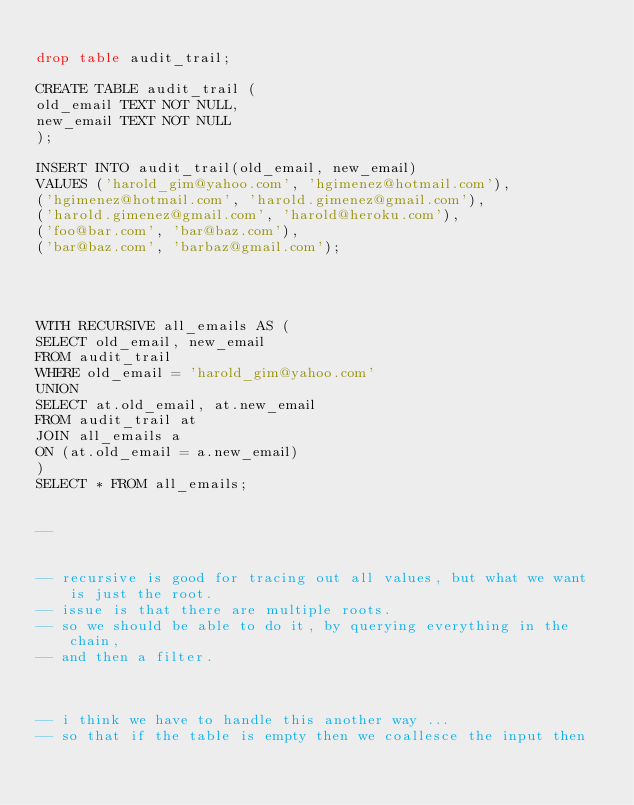<code> <loc_0><loc_0><loc_500><loc_500><_SQL_>
drop table audit_trail;

CREATE TABLE audit_trail (
old_email TEXT NOT NULL,
new_email TEXT NOT NULL
); 

INSERT INTO audit_trail(old_email, new_email)
VALUES ('harold_gim@yahoo.com', 'hgimenez@hotmail.com'),
('hgimenez@hotmail.com', 'harold.gimenez@gmail.com'),
('harold.gimenez@gmail.com', 'harold@heroku.com'),
('foo@bar.com', 'bar@baz.com'),
('bar@baz.com', 'barbaz@gmail.com'); 




WITH RECURSIVE all_emails AS (
SELECT old_email, new_email
FROM audit_trail
WHERE old_email = 'harold_gim@yahoo.com'
UNION
SELECT at.old_email, at.new_email
FROM audit_trail at
JOIN all_emails a
ON (at.old_email = a.new_email)
)
SELECT * FROM all_emails; 


-- 


-- recursive is good for tracing out all values, but what we want is just the root. 
-- issue is that there are multiple roots. 
-- so we should be able to do it, by querying everything in the chain, 
-- and then a filter. 
 


-- i think we have to handle this another way ...
-- so that if the table is empty then we coallesce the input then 


</code> 